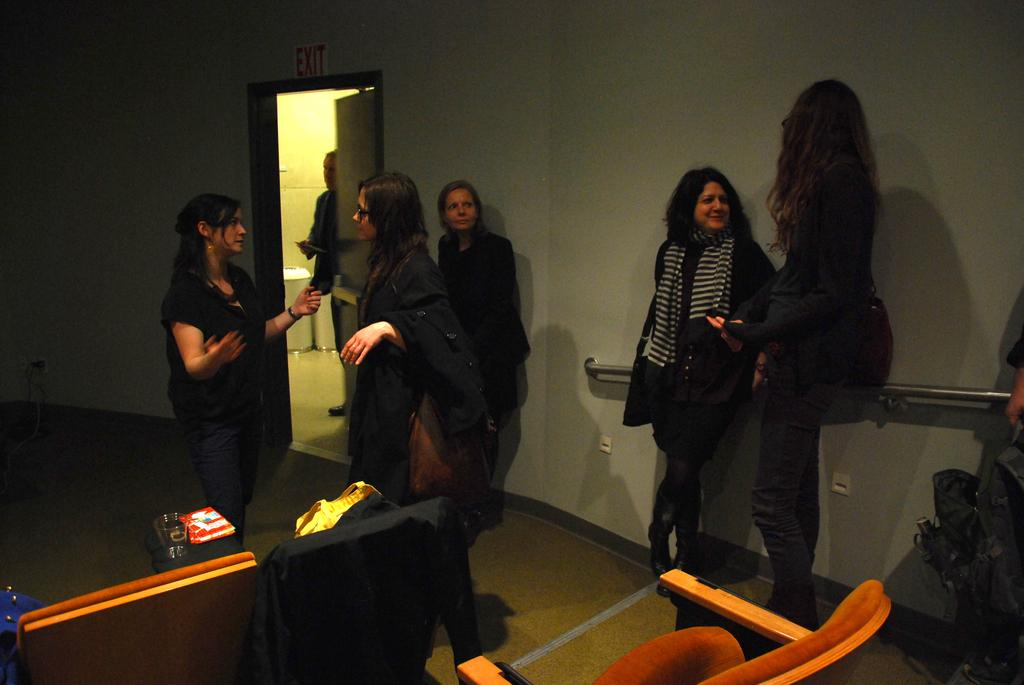What can be seen in the foreground of the image? There are women standing in the foreground of the image. What type of furniture is present in the image? There are chairs in the image. What items are being carried by the women in the image? There are bags in the image. What type of container is visible in the image? There is a glass in the image. What part of the room can be seen in the image? The floor is visible in the image. What architectural features are present in the image? There is a door and a wall in the image. What type of leaf is being traded in the image? There is no leaf or trade activity present in the image. What type of shop is visible in the image? There is no shop visible in the image. 